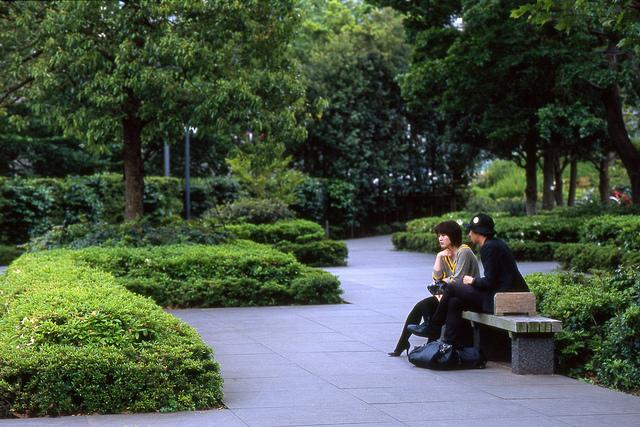What are the benches made out of?
Be succinct. Stone. How many people are in the picture?
Short answer required. 2. What country is this?
Short answer required. China. What color is the bench near the shrubs?
Give a very brief answer. Gray. What are they sitting on?
Quick response, please. Bench. What is the man sitting on?
Answer briefly. Bench. 